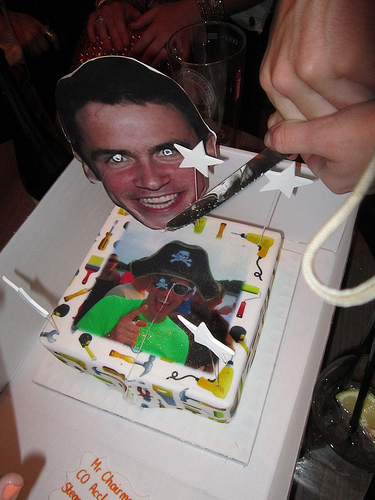Please provide a short description for this region: [0.23, 0.88, 0.38, 0.99]. In the specified region, you'll find vibrant orange text adorning the cake, possibly conveying a celebratory message or the name of the honoree. 